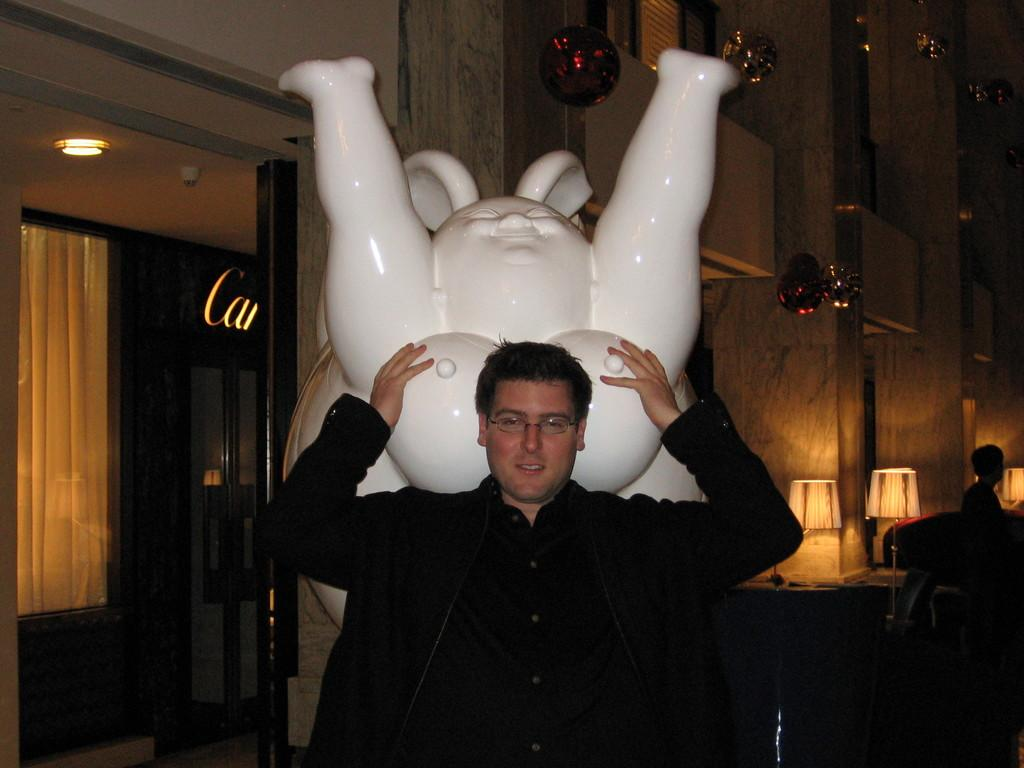What is the main subject of the image? There is a person standing in the center of the image. Can you describe the setting of the image? There is a building in the background of the image. Where is the basin located in the image? There is no basin present in the image. How many girls can be seen in the image? There is no girl present in the image; only a person is mentioned. What sound does the person make in the image? The image does not depict any sounds, so it cannot be determined what sound the person might make. 